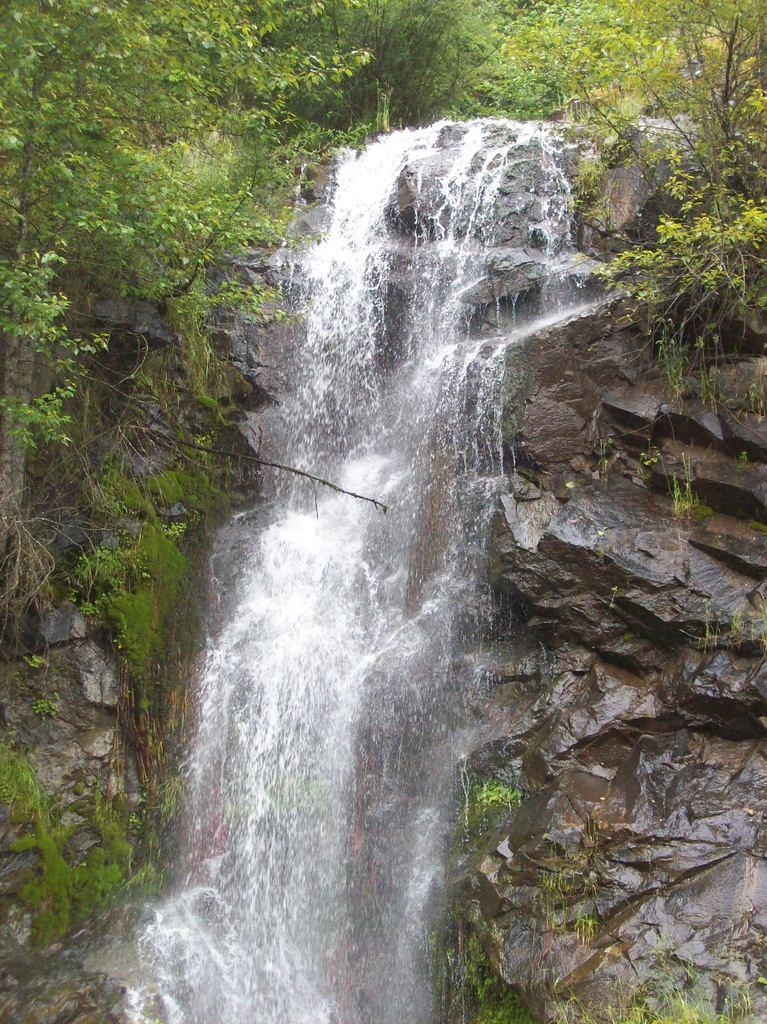What type of natural elements can be seen in the image? There are rocks and water visible in the image. What can be seen in the background of the image? There are trees in the background of the image. What type of silver object can be seen in the image? There is no silver object present in the image. What does the image smell like? The image does not have a smell, as it is a visual representation. 